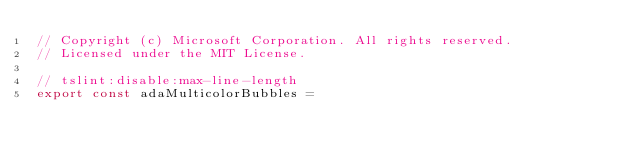<code> <loc_0><loc_0><loc_500><loc_500><_TypeScript_>// Copyright (c) Microsoft Corporation. All rights reserved.
// Licensed under the MIT License.

// tslint:disable:max-line-length
export const adaMulticolorBubbles =</code> 